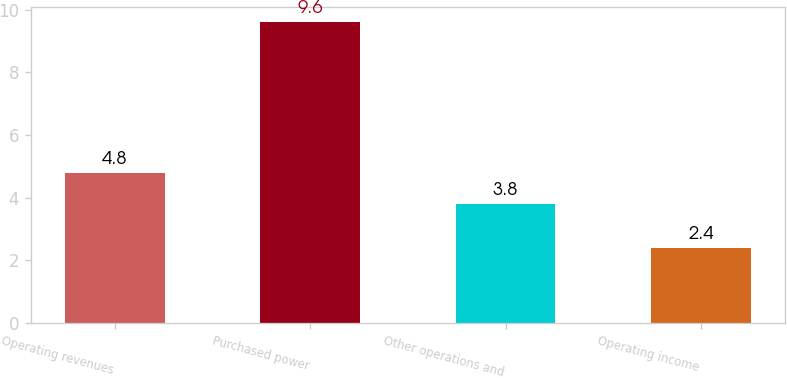<chart> <loc_0><loc_0><loc_500><loc_500><bar_chart><fcel>Operating revenues<fcel>Purchased power<fcel>Other operations and<fcel>Operating income<nl><fcel>4.8<fcel>9.6<fcel>3.8<fcel>2.4<nl></chart> 